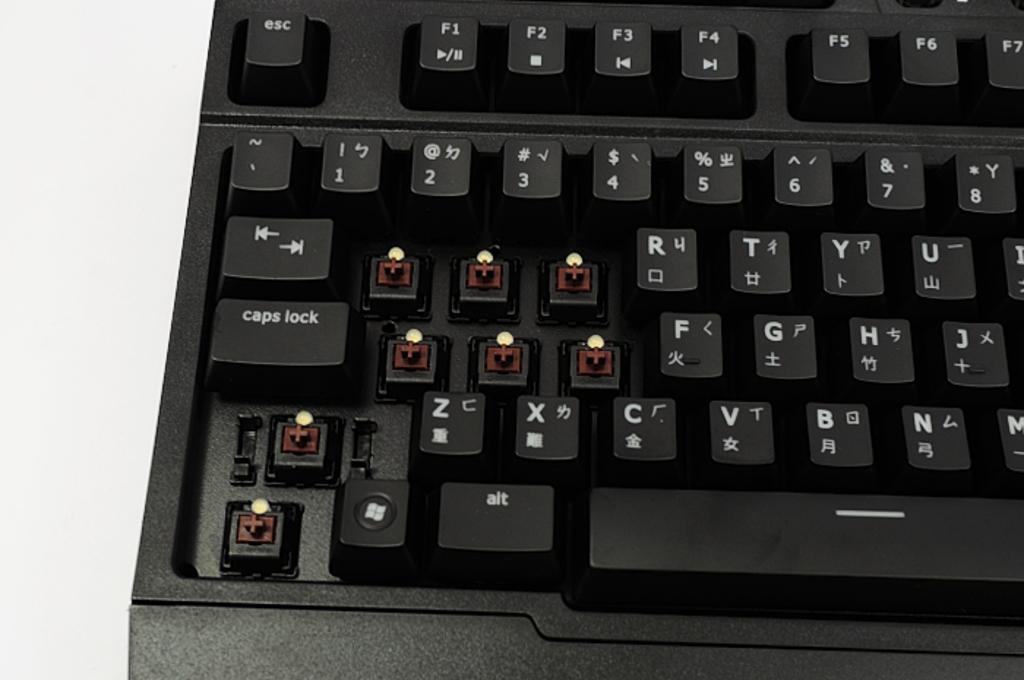What does the key on the top left do?
Give a very brief answer. Esc. What is the key in the middle left?
Provide a succinct answer. Caps lock. 